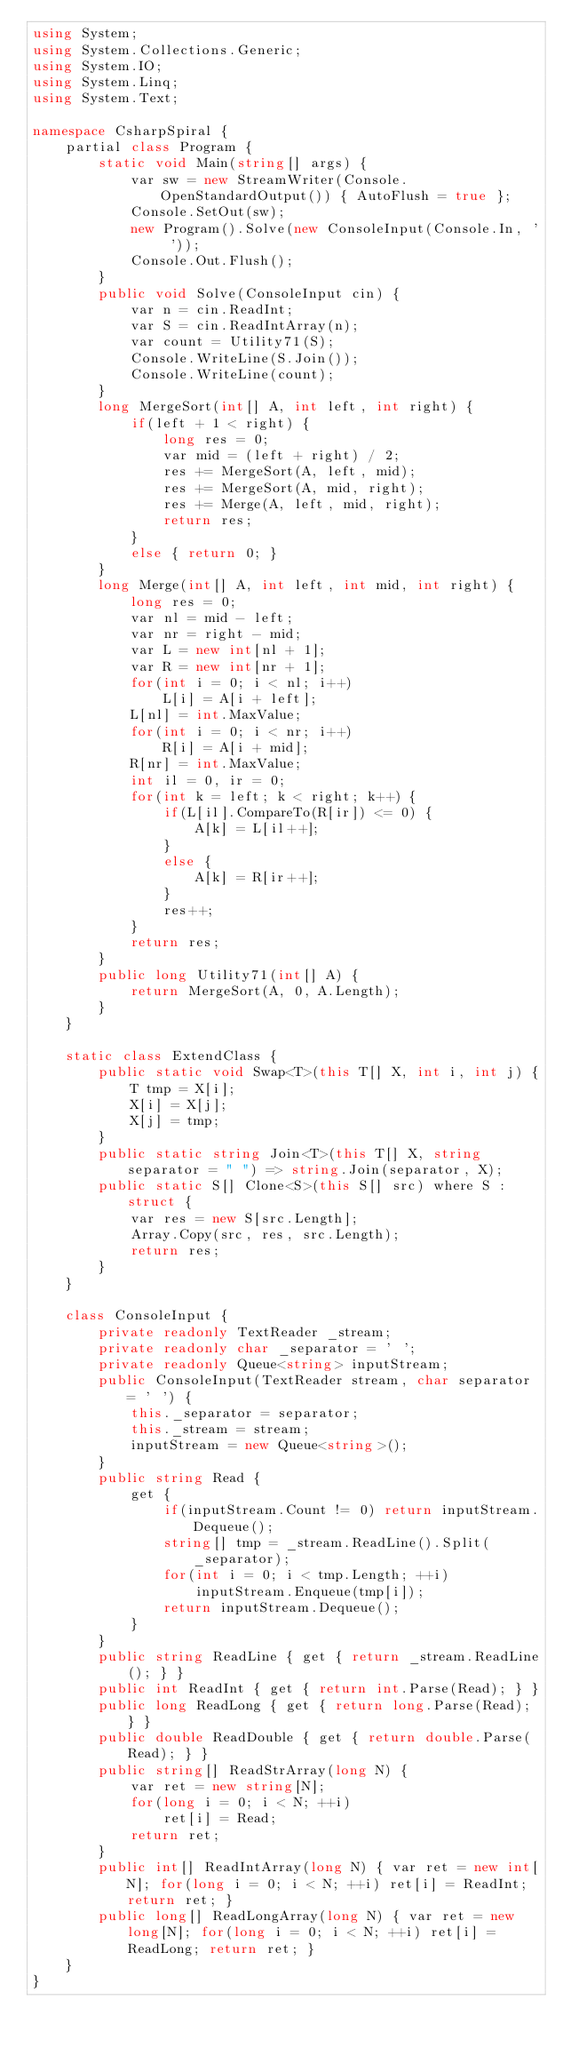<code> <loc_0><loc_0><loc_500><loc_500><_C#_>using System;
using System.Collections.Generic;
using System.IO;
using System.Linq;
using System.Text;

namespace CsharpSpiral {
    partial class Program {
        static void Main(string[] args) {
            var sw = new StreamWriter(Console.OpenStandardOutput()) { AutoFlush = true };
            Console.SetOut(sw);
            new Program().Solve(new ConsoleInput(Console.In, ' '));
            Console.Out.Flush();
        }
        public void Solve(ConsoleInput cin) {
            var n = cin.ReadInt;
            var S = cin.ReadIntArray(n);
            var count = Utility71(S);
            Console.WriteLine(S.Join());
            Console.WriteLine(count);
        }
        long MergeSort(int[] A, int left, int right) {
            if(left + 1 < right) {
                long res = 0;
                var mid = (left + right) / 2;
                res += MergeSort(A, left, mid);
                res += MergeSort(A, mid, right);
                res += Merge(A, left, mid, right);
                return res;
            }
            else { return 0; }
        }
        long Merge(int[] A, int left, int mid, int right) {
            long res = 0;
            var nl = mid - left;
            var nr = right - mid;
            var L = new int[nl + 1];
            var R = new int[nr + 1];
            for(int i = 0; i < nl; i++)
                L[i] = A[i + left];
            L[nl] = int.MaxValue;
            for(int i = 0; i < nr; i++)
                R[i] = A[i + mid];
            R[nr] = int.MaxValue;
            int il = 0, ir = 0;
            for(int k = left; k < right; k++) {
                if(L[il].CompareTo(R[ir]) <= 0) {
                    A[k] = L[il++];
                }
                else {
                    A[k] = R[ir++];
                }
                res++;
            }
            return res;
        }
        public long Utility71(int[] A) {
            return MergeSort(A, 0, A.Length);
        }
    }

    static class ExtendClass {
        public static void Swap<T>(this T[] X, int i, int j) {
            T tmp = X[i];
            X[i] = X[j];
            X[j] = tmp;
        }
        public static string Join<T>(this T[] X, string separator = " ") => string.Join(separator, X);
        public static S[] Clone<S>(this S[] src) where S : struct {
            var res = new S[src.Length];
            Array.Copy(src, res, src.Length);
            return res;
        }
    }

    class ConsoleInput {
        private readonly TextReader _stream;
        private readonly char _separator = ' ';
        private readonly Queue<string> inputStream;
        public ConsoleInput(TextReader stream, char separator = ' ') {
            this._separator = separator;
            this._stream = stream;
            inputStream = new Queue<string>();
        }
        public string Read {
            get {
                if(inputStream.Count != 0) return inputStream.Dequeue();
                string[] tmp = _stream.ReadLine().Split(_separator);
                for(int i = 0; i < tmp.Length; ++i)
                    inputStream.Enqueue(tmp[i]);
                return inputStream.Dequeue();
            }
        }
        public string ReadLine { get { return _stream.ReadLine(); } }
        public int ReadInt { get { return int.Parse(Read); } }
        public long ReadLong { get { return long.Parse(Read); } }
        public double ReadDouble { get { return double.Parse(Read); } }
        public string[] ReadStrArray(long N) {
            var ret = new string[N];
            for(long i = 0; i < N; ++i)
                ret[i] = Read;
            return ret;
        }
        public int[] ReadIntArray(long N) { var ret = new int[N]; for(long i = 0; i < N; ++i) ret[i] = ReadInt; return ret; }
        public long[] ReadLongArray(long N) { var ret = new long[N]; for(long i = 0; i < N; ++i) ret[i] = ReadLong; return ret; }
    }
}

</code> 